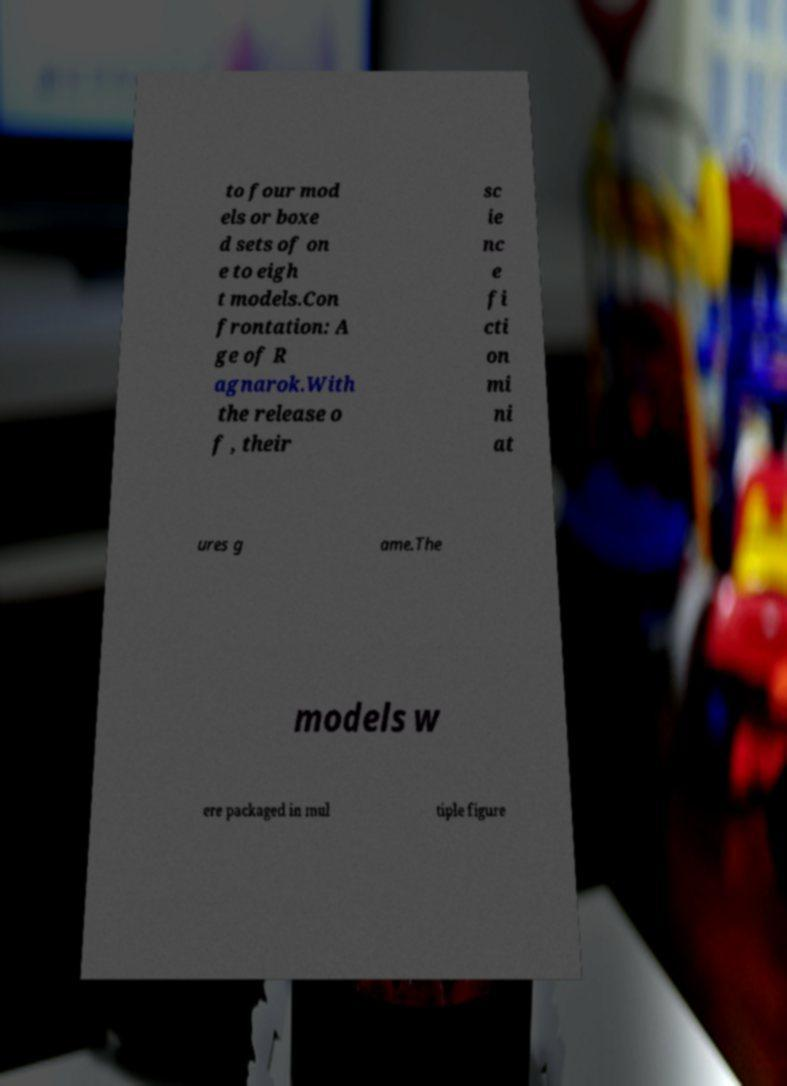For documentation purposes, I need the text within this image transcribed. Could you provide that? to four mod els or boxe d sets of on e to eigh t models.Con frontation: A ge of R agnarok.With the release o f , their sc ie nc e fi cti on mi ni at ures g ame.The models w ere packaged in mul tiple figure 